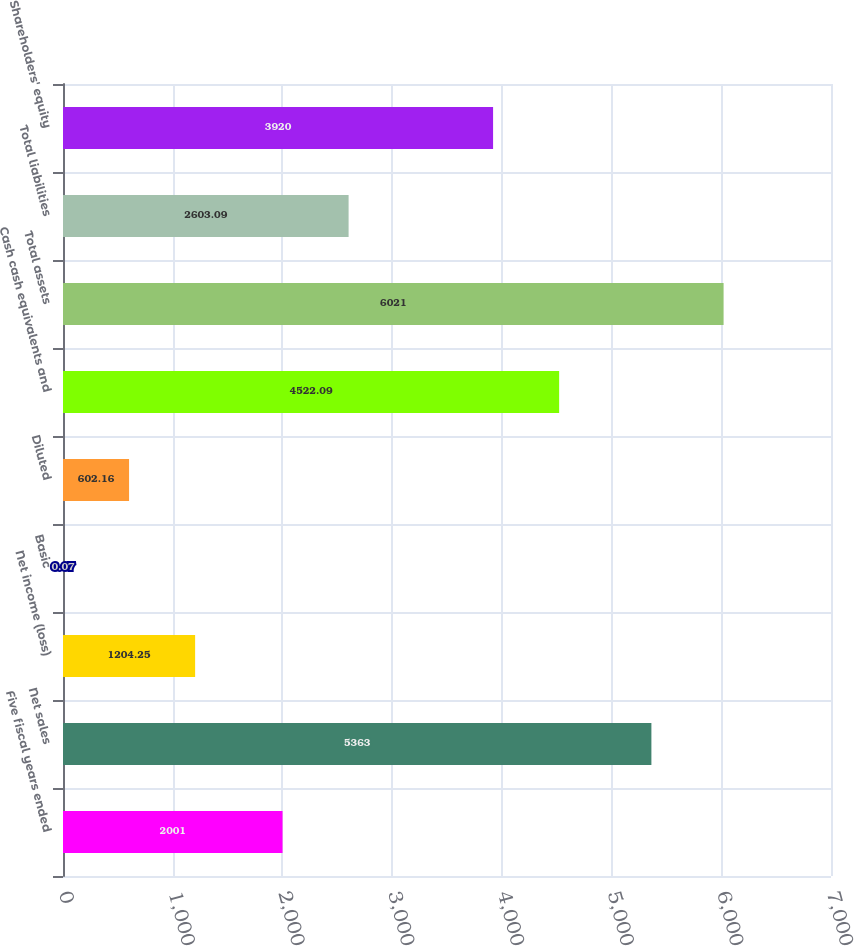Convert chart. <chart><loc_0><loc_0><loc_500><loc_500><bar_chart><fcel>Five fiscal years ended<fcel>Net sales<fcel>Net income (loss)<fcel>Basic<fcel>Diluted<fcel>Cash cash equivalents and<fcel>Total assets<fcel>Total liabilities<fcel>Shareholders' equity<nl><fcel>2001<fcel>5363<fcel>1204.25<fcel>0.07<fcel>602.16<fcel>4522.09<fcel>6021<fcel>2603.09<fcel>3920<nl></chart> 